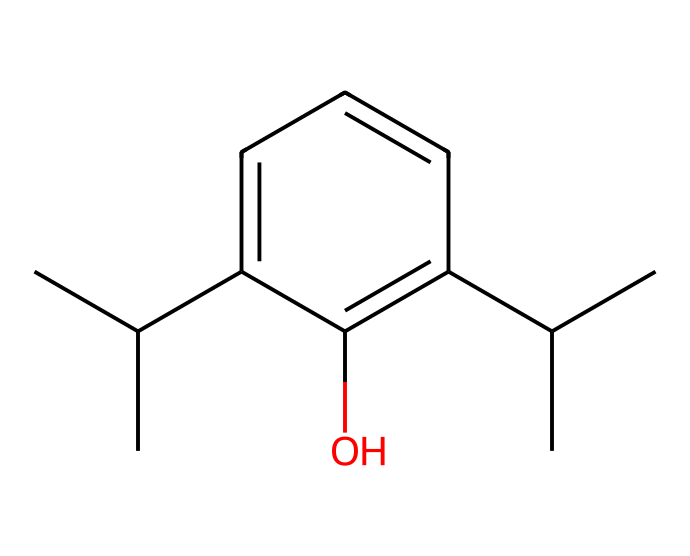what is the molecular formula of propofol? The SMILES representation can be analyzed by counting the carbon (C), hydrogen (H), and oxygen (O) atoms. In the provided SMILES, there are 12 carbon atoms, 18 hydrogen atoms, and 1 oxygen atom, which leads to the molecular formula C12H18O.
Answer: C12H18O how many carbon atoms are present in this structure? By inspecting the SMILES representation, each "C" indicates a carbon atom. Counting all the carbon atoms gives a total of 12.
Answer: 12 how many hydroxyl groups are in this molecule? The hydroxyl group (-OH) is represented by the "O" in the SMILES, which is attached directly to the phenolic part of the structure. There is only one "O" in the structure, indicating one hydroxyl group.
Answer: 1 what type of chemical structure is propofol considered? Propofol is an anesthetic agent, and by examining its structure, it can be identified as an aryl-propanol due to its aliphatic and aromatic components.
Answer: aryl-propanol what is the significance of the carbene structure in propofol's activity? Carbenes are reactive species that can influence the pharmacological properties of compounds. Propofol has a propan-2-ol core, and while it doesn't exhibit a classic carbene structure, the potential for transient carbene-like behavior can affect its interaction with biological targets, influencing its anesthetic potency and stability.
Answer: transient carbene-like behavior how does the presence of aromatic rings affect the properties of propofol? Aromatic rings, such as those present in propofol, contribute to its lipophilicity, which enhances absorption and distribution in the body. The aromatic component allows for better interaction with biological membranes, making the anesthetic effective at lower doses.
Answer: lipophilicity 